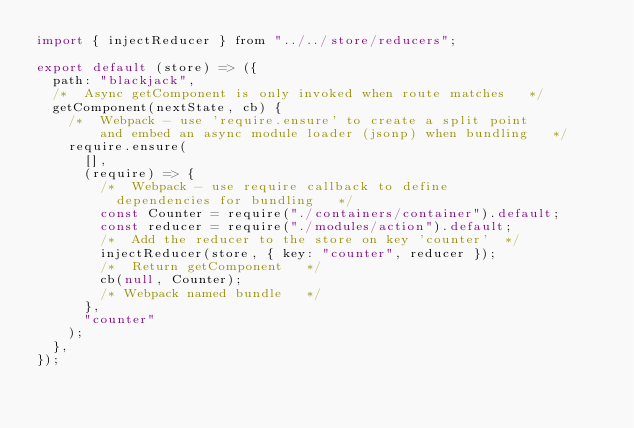Convert code to text. <code><loc_0><loc_0><loc_500><loc_500><_JavaScript_>import { injectReducer } from "../../store/reducers";

export default (store) => ({
  path: "blackjack",
  /*  Async getComponent is only invoked when route matches   */
  getComponent(nextState, cb) {
    /*  Webpack - use 'require.ensure' to create a split point
        and embed an async module loader (jsonp) when bundling   */
    require.ensure(
      [],
      (require) => {
        /*  Webpack - use require callback to define
          dependencies for bundling   */
        const Counter = require("./containers/container").default;
        const reducer = require("./modules/action").default;
        /*  Add the reducer to the store on key 'counter'  */
        injectReducer(store, { key: "counter", reducer });
        /*  Return getComponent   */
        cb(null, Counter);
        /* Webpack named bundle   */
      },
      "counter"
    );
  },
});
</code> 